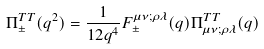<formula> <loc_0><loc_0><loc_500><loc_500>\Pi ^ { T T } _ { \pm } ( q ^ { 2 } ) = \frac { 1 } { 1 2 q ^ { 4 } } F _ { \pm } ^ { \mu \nu ; \rho \lambda } ( q ) \Pi ^ { T T } _ { \mu \nu ; \rho \lambda } ( q )</formula> 